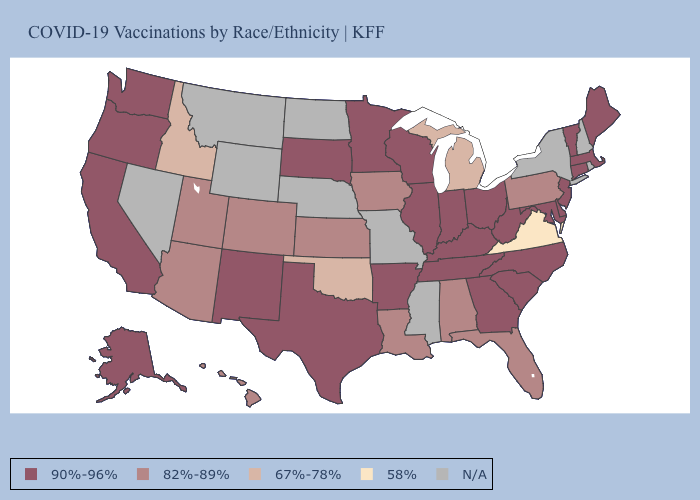How many symbols are there in the legend?
Write a very short answer. 5. Which states have the highest value in the USA?
Short answer required. Alaska, Arkansas, California, Connecticut, Delaware, Georgia, Illinois, Indiana, Kentucky, Maine, Maryland, Massachusetts, Minnesota, New Jersey, New Mexico, North Carolina, Ohio, Oregon, South Carolina, South Dakota, Tennessee, Texas, Vermont, Washington, West Virginia, Wisconsin. Name the states that have a value in the range 67%-78%?
Keep it brief. Idaho, Michigan, Oklahoma. Does the first symbol in the legend represent the smallest category?
Write a very short answer. No. Does Arizona have the lowest value in the USA?
Quick response, please. No. Among the states that border Georgia , does South Carolina have the highest value?
Concise answer only. Yes. Name the states that have a value in the range 82%-89%?
Give a very brief answer. Alabama, Arizona, Colorado, Florida, Hawaii, Iowa, Kansas, Louisiana, Pennsylvania, Utah. Name the states that have a value in the range 67%-78%?
Answer briefly. Idaho, Michigan, Oklahoma. What is the value of Missouri?
Keep it brief. N/A. Name the states that have a value in the range 82%-89%?
Concise answer only. Alabama, Arizona, Colorado, Florida, Hawaii, Iowa, Kansas, Louisiana, Pennsylvania, Utah. Among the states that border Wisconsin , which have the highest value?
Give a very brief answer. Illinois, Minnesota. Does Michigan have the highest value in the MidWest?
Short answer required. No. What is the highest value in states that border North Carolina?
Quick response, please. 90%-96%. Which states hav the highest value in the South?
Keep it brief. Arkansas, Delaware, Georgia, Kentucky, Maryland, North Carolina, South Carolina, Tennessee, Texas, West Virginia. 